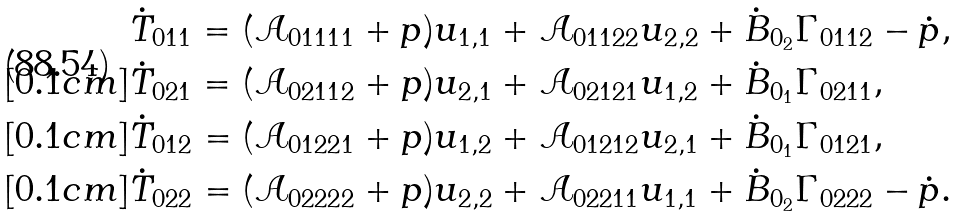<formula> <loc_0><loc_0><loc_500><loc_500>& \dot { T } _ { 0 1 1 } = ( \mathcal { A } _ { 0 1 1 1 1 } + p ) u _ { 1 , 1 } + \mathcal { A } _ { 0 1 1 2 2 } u _ { 2 , 2 } + \dot { B } _ { 0 _ { 2 } } \Gamma _ { 0 1 1 2 } - \dot { p } , \\ [ 0 . 1 c m ] & \dot { T } _ { 0 2 1 } = ( \mathcal { A } _ { 0 2 1 1 2 } + p ) u _ { 2 , 1 } + \mathcal { A } _ { 0 2 1 2 1 } u _ { 1 , 2 } + \dot { B } _ { 0 _ { 1 } } \Gamma _ { 0 2 1 1 } , \\ [ 0 . 1 c m ] & \dot { T } _ { 0 1 2 } = ( \mathcal { A } _ { 0 1 2 2 1 } + p ) u _ { 1 , 2 } + \mathcal { A } _ { 0 1 2 1 2 } u _ { 2 , 1 } + \dot { B } _ { 0 _ { 1 } } \Gamma _ { 0 1 2 1 } , \\ [ 0 . 1 c m ] & \dot { T } _ { 0 2 2 } = ( \mathcal { A } _ { 0 2 2 2 2 } + p ) u _ { 2 , 2 } + \mathcal { A } _ { 0 2 2 1 1 } u _ { 1 , 1 } + \dot { B } _ { 0 _ { 2 } } \Gamma _ { 0 2 2 2 } - \dot { p } .</formula> 